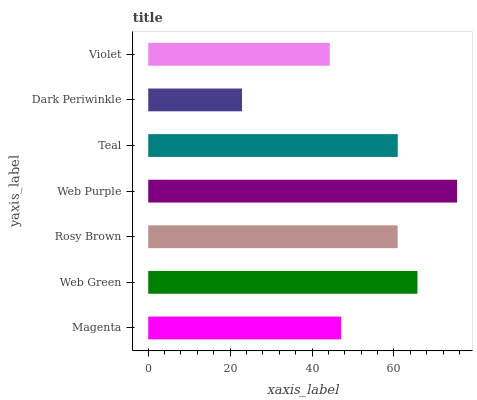Is Dark Periwinkle the minimum?
Answer yes or no. Yes. Is Web Purple the maximum?
Answer yes or no. Yes. Is Web Green the minimum?
Answer yes or no. No. Is Web Green the maximum?
Answer yes or no. No. Is Web Green greater than Magenta?
Answer yes or no. Yes. Is Magenta less than Web Green?
Answer yes or no. Yes. Is Magenta greater than Web Green?
Answer yes or no. No. Is Web Green less than Magenta?
Answer yes or no. No. Is Rosy Brown the high median?
Answer yes or no. Yes. Is Rosy Brown the low median?
Answer yes or no. Yes. Is Web Green the high median?
Answer yes or no. No. Is Magenta the low median?
Answer yes or no. No. 